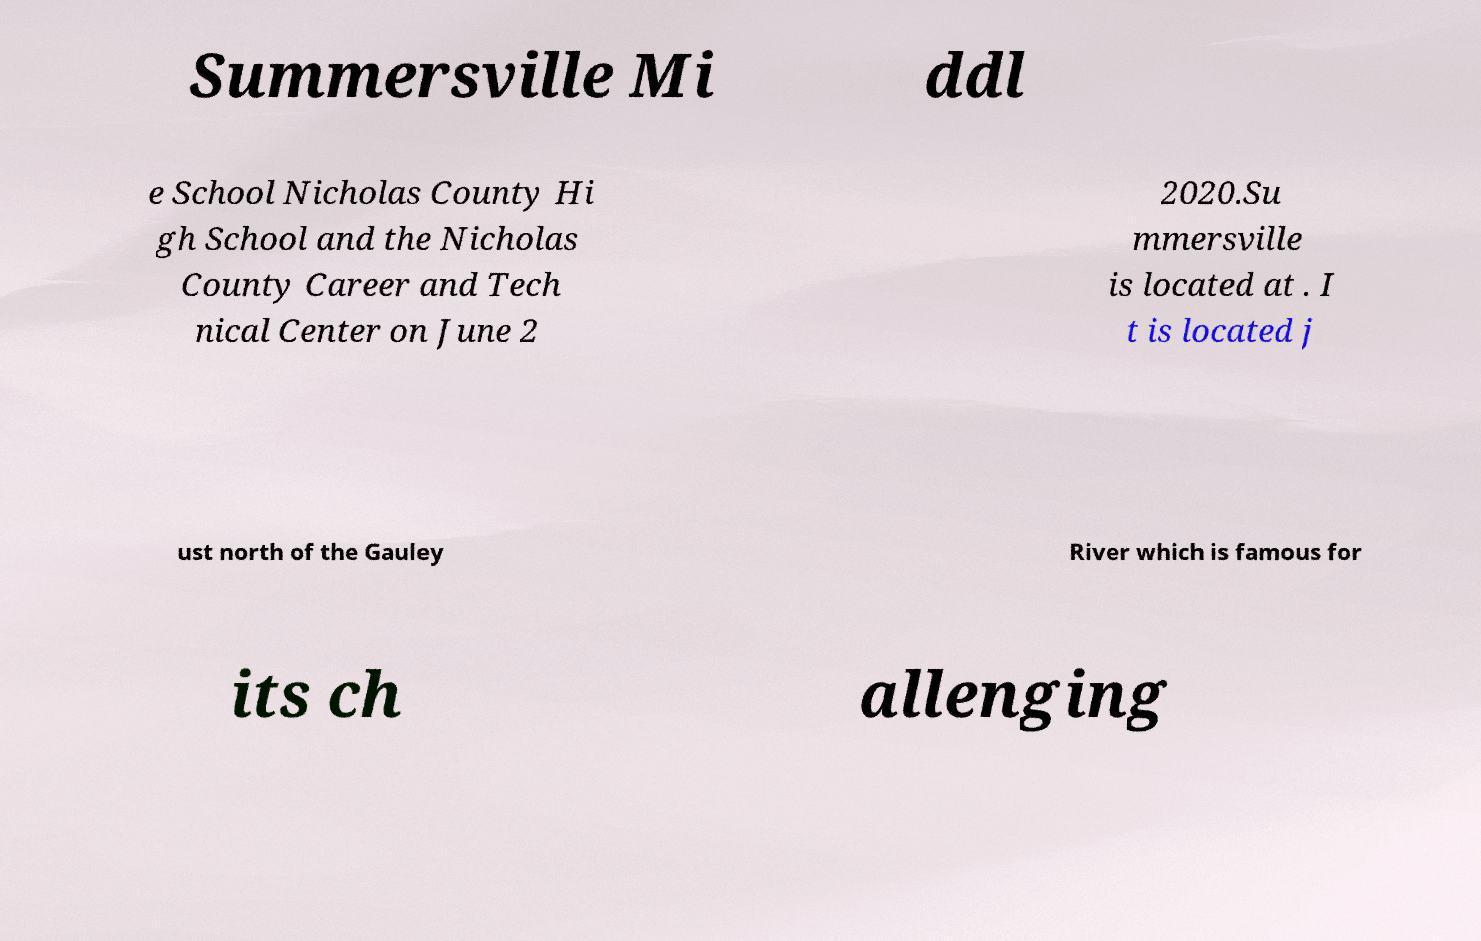Could you assist in decoding the text presented in this image and type it out clearly? Summersville Mi ddl e School Nicholas County Hi gh School and the Nicholas County Career and Tech nical Center on June 2 2020.Su mmersville is located at . I t is located j ust north of the Gauley River which is famous for its ch allenging 